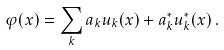Convert formula to latex. <formula><loc_0><loc_0><loc_500><loc_500>\varphi ( x ) = \sum _ { k } a _ { k } u _ { k } ( x ) + a _ { k } ^ { * } u _ { k } ^ { * } ( x ) \, .</formula> 